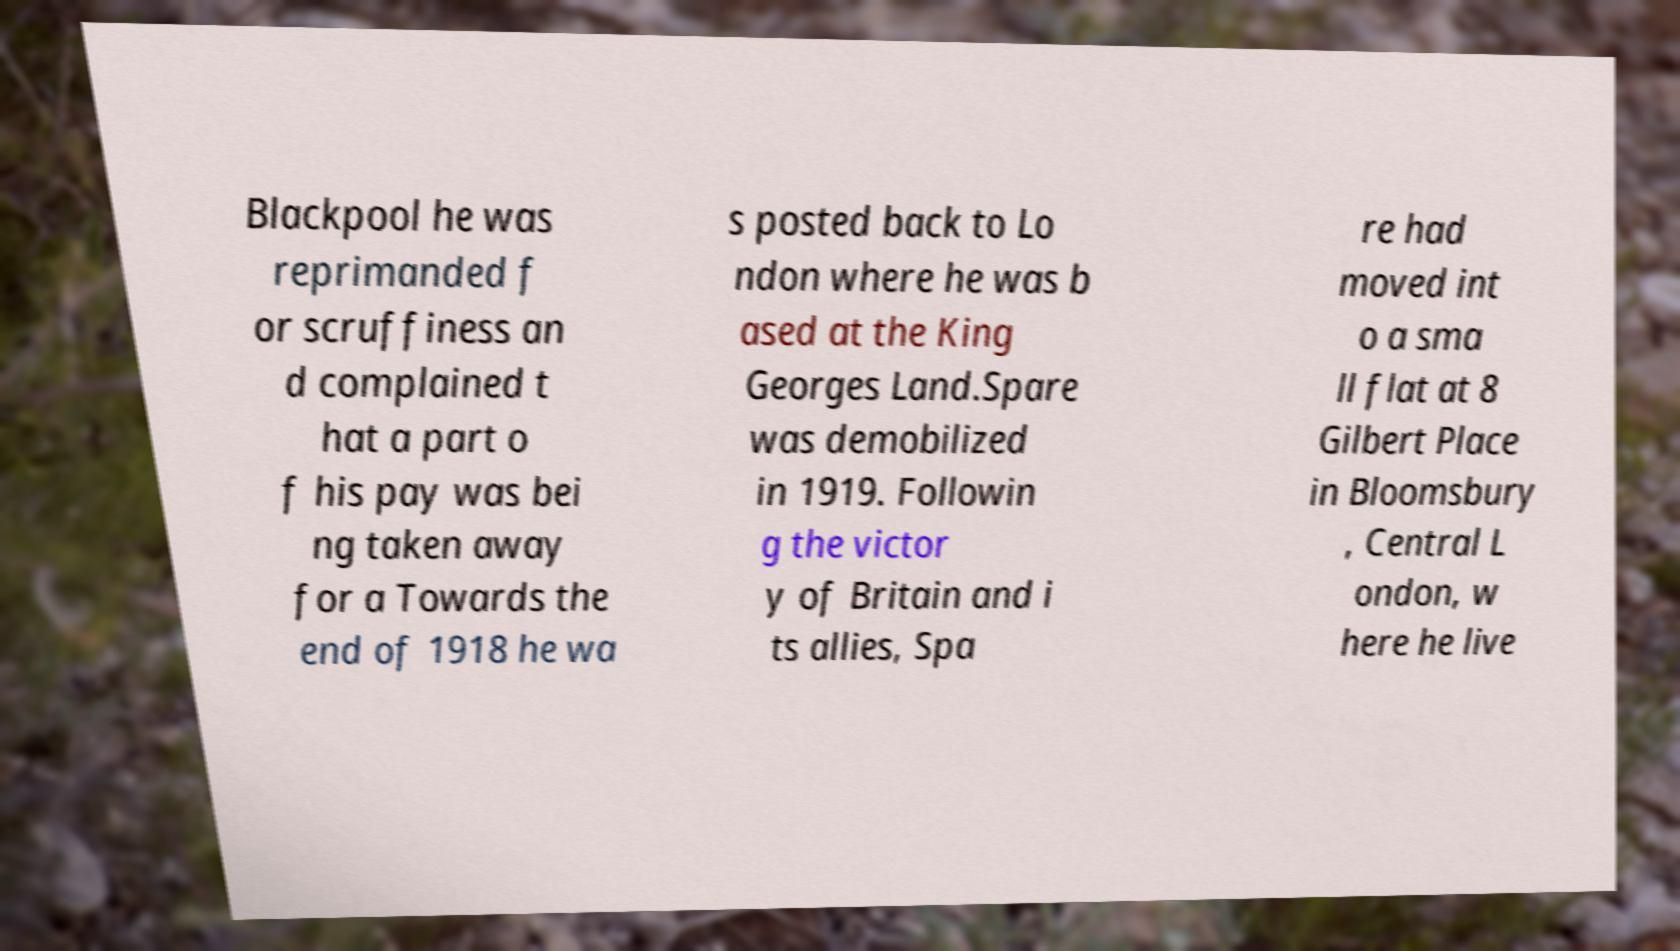Could you extract and type out the text from this image? Blackpool he was reprimanded f or scruffiness an d complained t hat a part o f his pay was bei ng taken away for a Towards the end of 1918 he wa s posted back to Lo ndon where he was b ased at the King Georges Land.Spare was demobilized in 1919. Followin g the victor y of Britain and i ts allies, Spa re had moved int o a sma ll flat at 8 Gilbert Place in Bloomsbury , Central L ondon, w here he live 